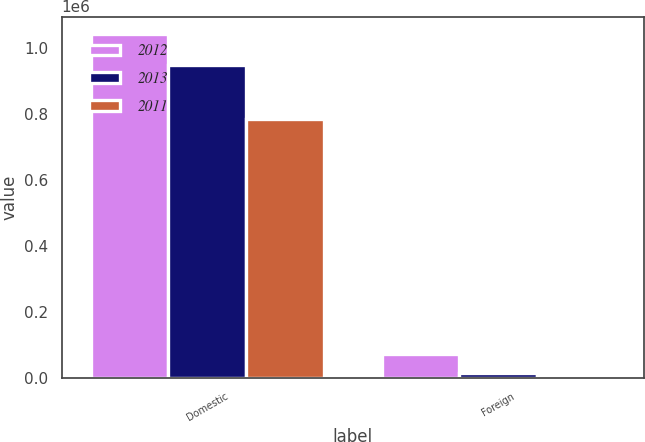Convert chart. <chart><loc_0><loc_0><loc_500><loc_500><stacked_bar_chart><ecel><fcel>Domestic<fcel>Foreign<nl><fcel>2012<fcel>1.04232e+06<fcel>71988<nl><fcel>2013<fcel>946592<fcel>14920<nl><fcel>2011<fcel>782896<fcel>9768<nl></chart> 